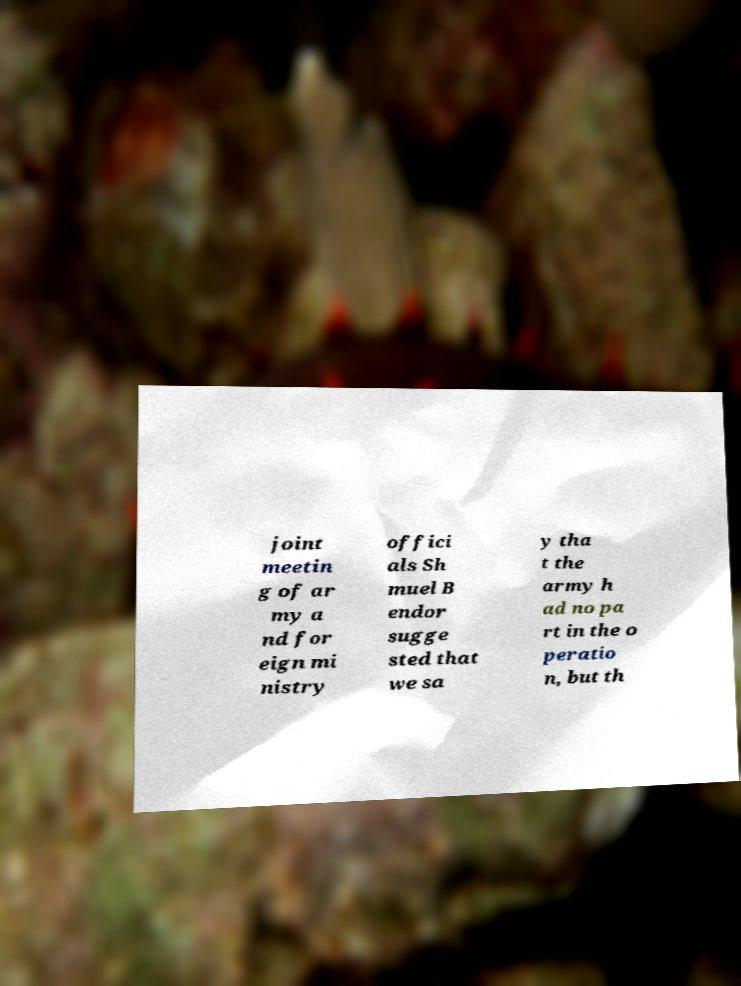Please identify and transcribe the text found in this image. joint meetin g of ar my a nd for eign mi nistry offici als Sh muel B endor sugge sted that we sa y tha t the army h ad no pa rt in the o peratio n, but th 